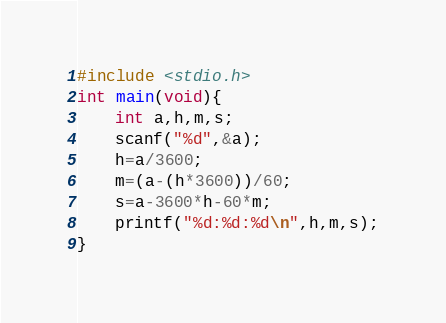<code> <loc_0><loc_0><loc_500><loc_500><_C_>#include <stdio.h>
int main(void){
    int a,h,m,s;
    scanf("%d",&a);
    h=a/3600;
    m=(a-(h*3600))/60;
    s=a-3600*h-60*m;
    printf("%d:%d:%d\n",h,m,s);
}
</code> 